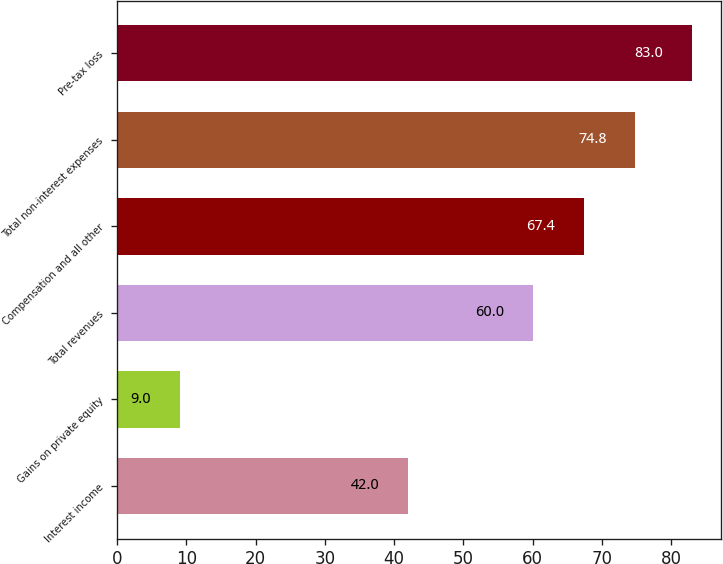Convert chart. <chart><loc_0><loc_0><loc_500><loc_500><bar_chart><fcel>Interest income<fcel>Gains on private equity<fcel>Total revenues<fcel>Compensation and all other<fcel>Total non-interest expenses<fcel>Pre-tax loss<nl><fcel>42<fcel>9<fcel>60<fcel>67.4<fcel>74.8<fcel>83<nl></chart> 